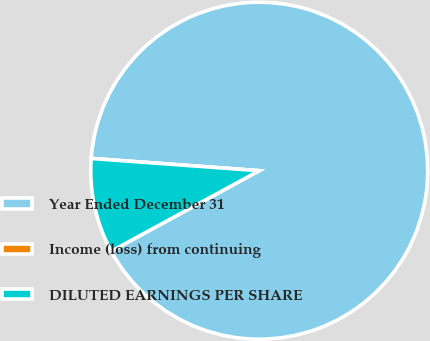Convert chart. <chart><loc_0><loc_0><loc_500><loc_500><pie_chart><fcel>Year Ended December 31<fcel>Income (loss) from continuing<fcel>DILUTED EARNINGS PER SHARE<nl><fcel>90.91%<fcel>0.0%<fcel>9.09%<nl></chart> 